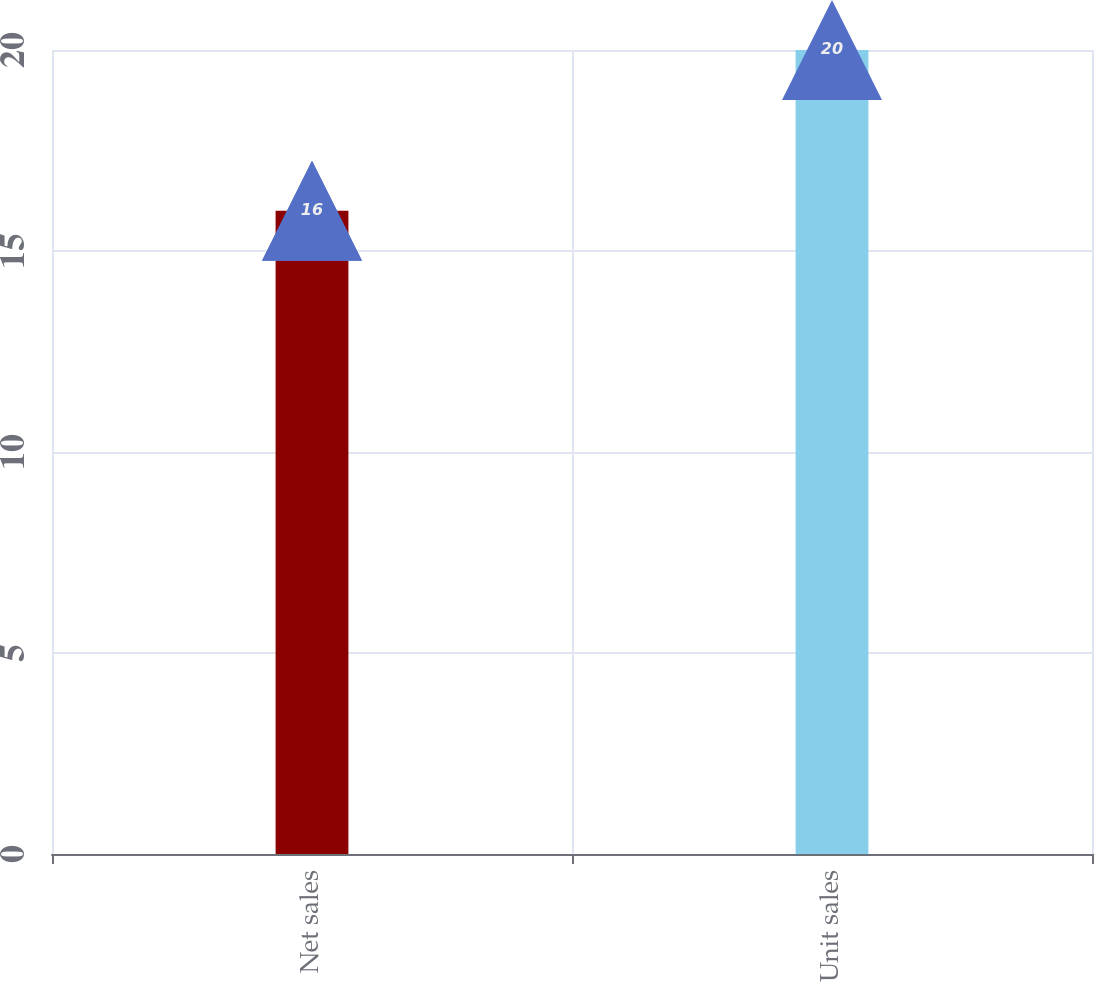<chart> <loc_0><loc_0><loc_500><loc_500><bar_chart><fcel>Net sales<fcel>Unit sales<nl><fcel>16<fcel>20<nl></chart> 